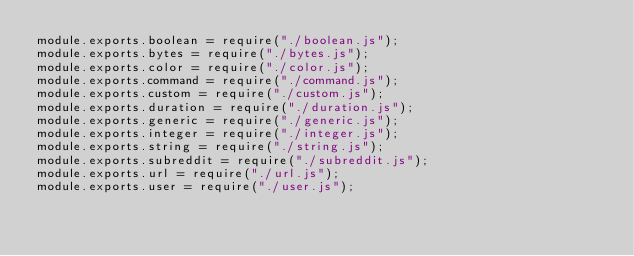<code> <loc_0><loc_0><loc_500><loc_500><_JavaScript_>module.exports.boolean = require("./boolean.js");
module.exports.bytes = require("./bytes.js");
module.exports.color = require("./color.js");
module.exports.command = require("./command.js");
module.exports.custom = require("./custom.js");
module.exports.duration = require("./duration.js");
module.exports.generic = require("./generic.js");
module.exports.integer = require("./integer.js");
module.exports.string = require("./string.js");
module.exports.subreddit = require("./subreddit.js");
module.exports.url = require("./url.js");
module.exports.user = require("./user.js");
</code> 